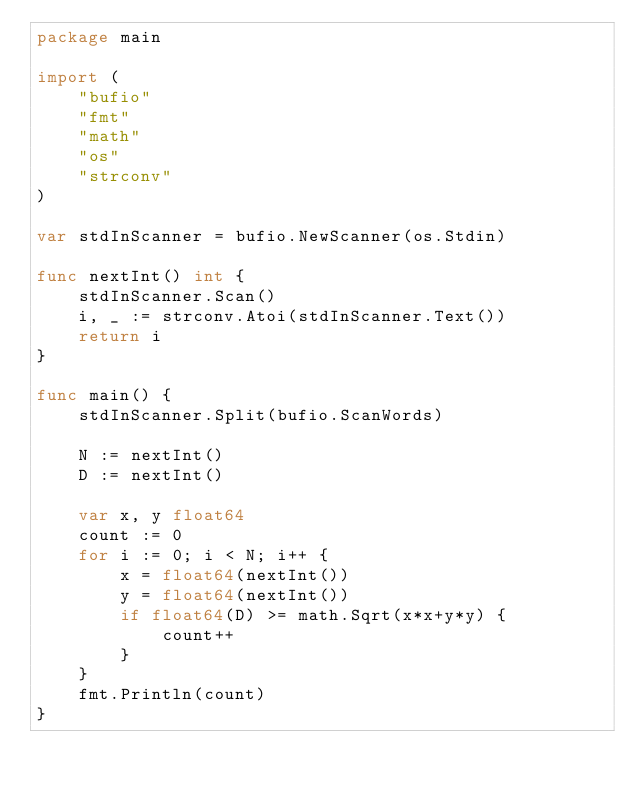<code> <loc_0><loc_0><loc_500><loc_500><_Go_>package main

import (
	"bufio"
	"fmt"
	"math"
	"os"
	"strconv"
)

var stdInScanner = bufio.NewScanner(os.Stdin)

func nextInt() int {
	stdInScanner.Scan()
	i, _ := strconv.Atoi(stdInScanner.Text())
	return i
}

func main() {
	stdInScanner.Split(bufio.ScanWords)

	N := nextInt()
	D := nextInt()

	var x, y float64
	count := 0
	for i := 0; i < N; i++ {
		x = float64(nextInt())
		y = float64(nextInt())
		if float64(D) >= math.Sqrt(x*x+y*y) {
			count++
		}
	}
	fmt.Println(count)
}
</code> 